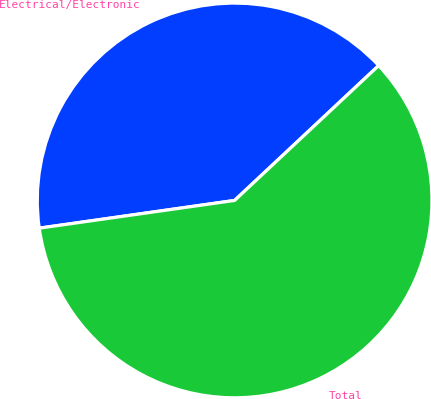Convert chart to OTSL. <chart><loc_0><loc_0><loc_500><loc_500><pie_chart><fcel>Electrical/Electronic<fcel>Total<nl><fcel>40.27%<fcel>59.73%<nl></chart> 